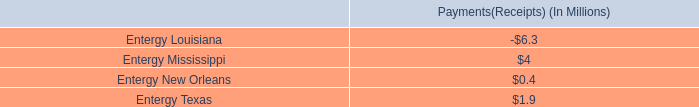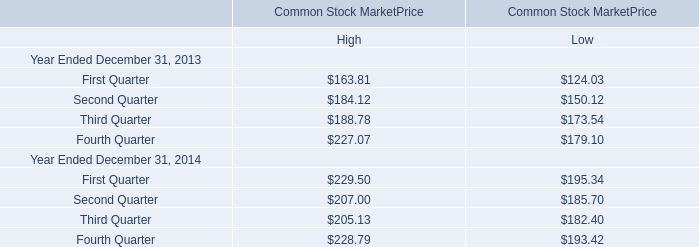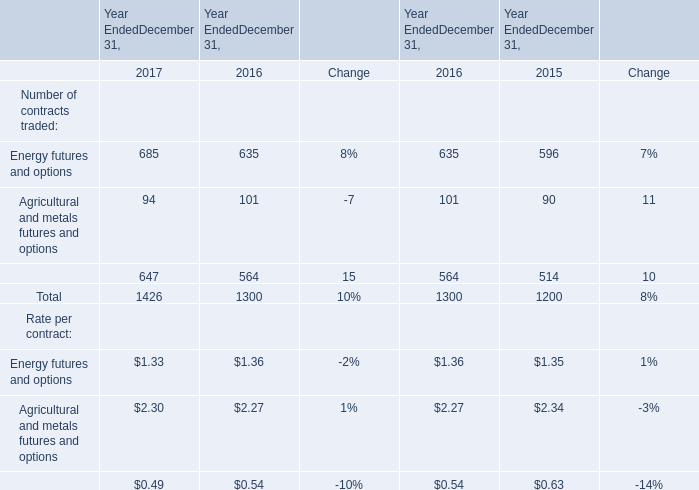If Total Number of contracts traded develops with the same growth rate in 2017, what will it reach in 2018? 
Computations: (1426 * (1 + (10 / 100)))
Answer: 1568.6. 